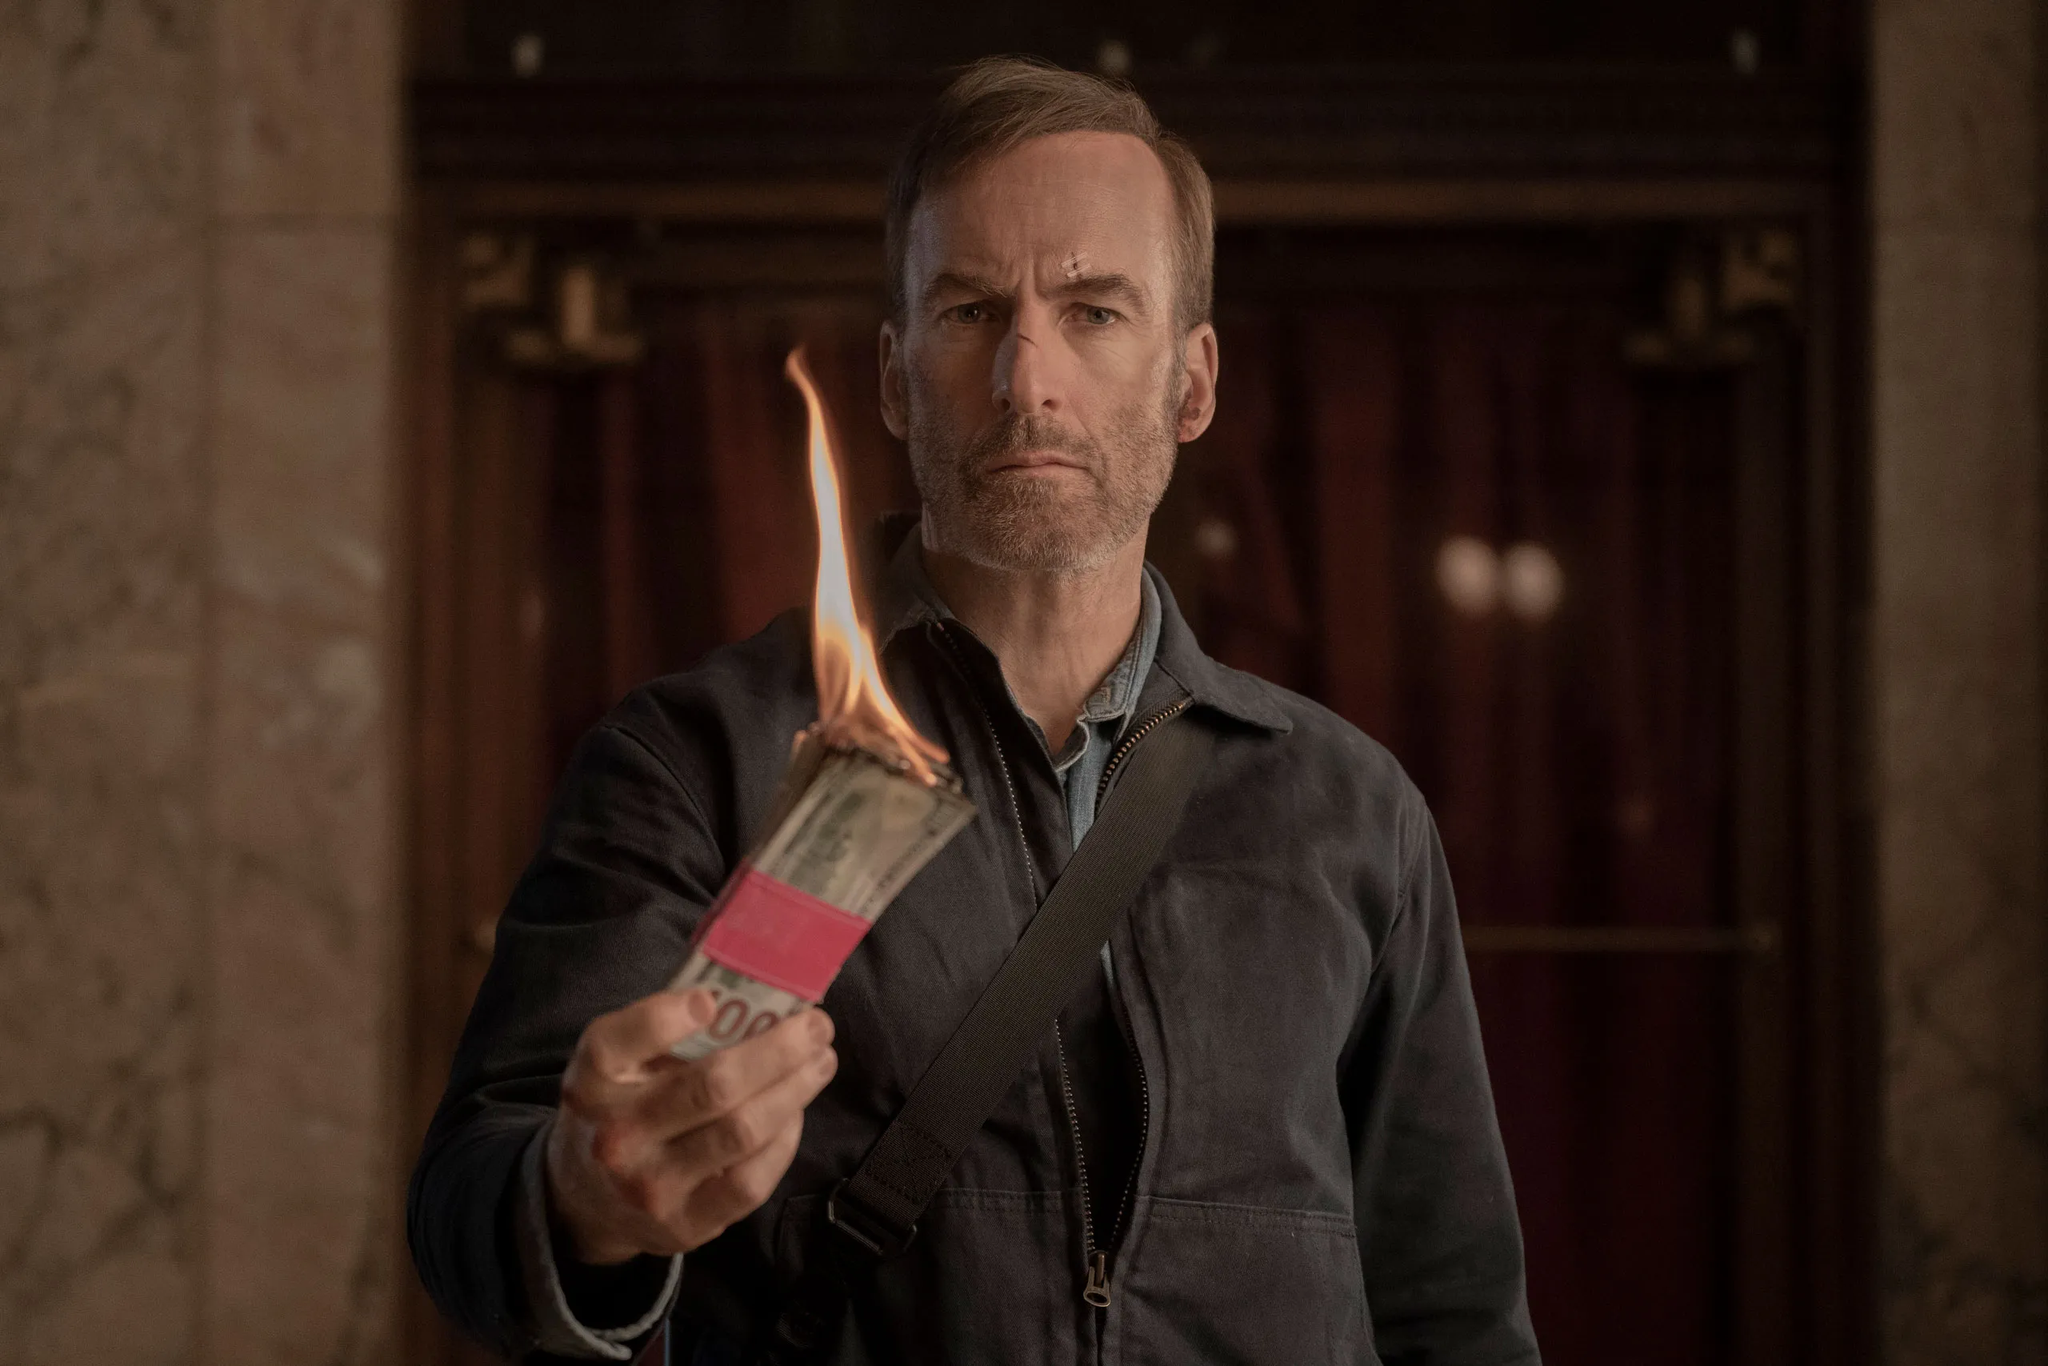Describe any cinematic elements that stand out in this scene. The lighting in the scene is particularly striking, with the flame of the burning money providing a dramatic source of illumination. The play of shadows on the actor's face and the dimly lit hallway in the background create a moody, tense atmosphere. The composition centers on the actor and the significant prop of the burning money, drawing the viewer's attention to the act's symbolism. The actor’s stern expression enhances the dramatic intensity, evoking a sense of urgency and foreboding. How do you think the setting contributes to the overall impact of this scene? The setting, a dimly lit hallway or lobby, adds to the atmosphere of tension and impending drama. It appears somewhat abandoned or foreboding, suggesting that the character's actions are happening in a place of significant importance or a moment of climax. This setting aids in creating a sense of isolation and focus around the character's drastic action, making the scene even more impactful and emotionally charged. Imagine this scene is part of a mystery thriller. What could have led to this moment? In the gripping mystery thriller, 'Inferno of Justice,' the protagonist, Detective Mark Harris, finds himself entangled in a conspiracy that runs deep within the city's most powerful institutions. After uncovering evidence of a massive embezzlement scheme that implicates high-ranking officials and business tycoons, he realizes that traditional methods won't suffice to bring these criminals to justice. Mark decides to take matters into his own hands. Investigating tirelessly, he tracks elicit transactions to an opulent bank, the beating heart of the illicit network. In a dramatic turn of events, he confronts the orchestrators, seizing a bundle of marked bills. By setting the money ablaze in the bank’s austere lobby, Mark sends a powerful message: he is willing to burn down their empire one corrupt dollar at a time. This bold act propels him deeper into the labyrinth of deception, where he must navigate betrayal, danger, and moral dilemmas to unearth the truth and restore justice. 